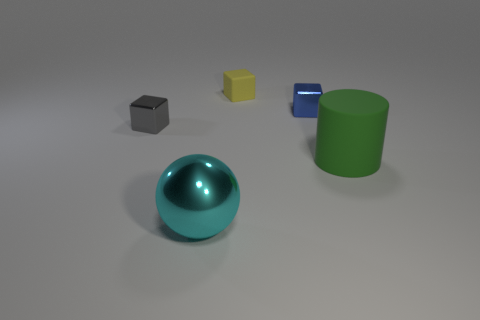There is another metallic object that is the same shape as the tiny gray metallic thing; what color is it? blue 